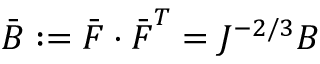Convert formula to latex. <formula><loc_0><loc_0><loc_500><loc_500>{ \bar { B } } \colon = { \bar { F } } \cdot { \bar { F } } ^ { T } = J ^ { - 2 / 3 } { B }</formula> 